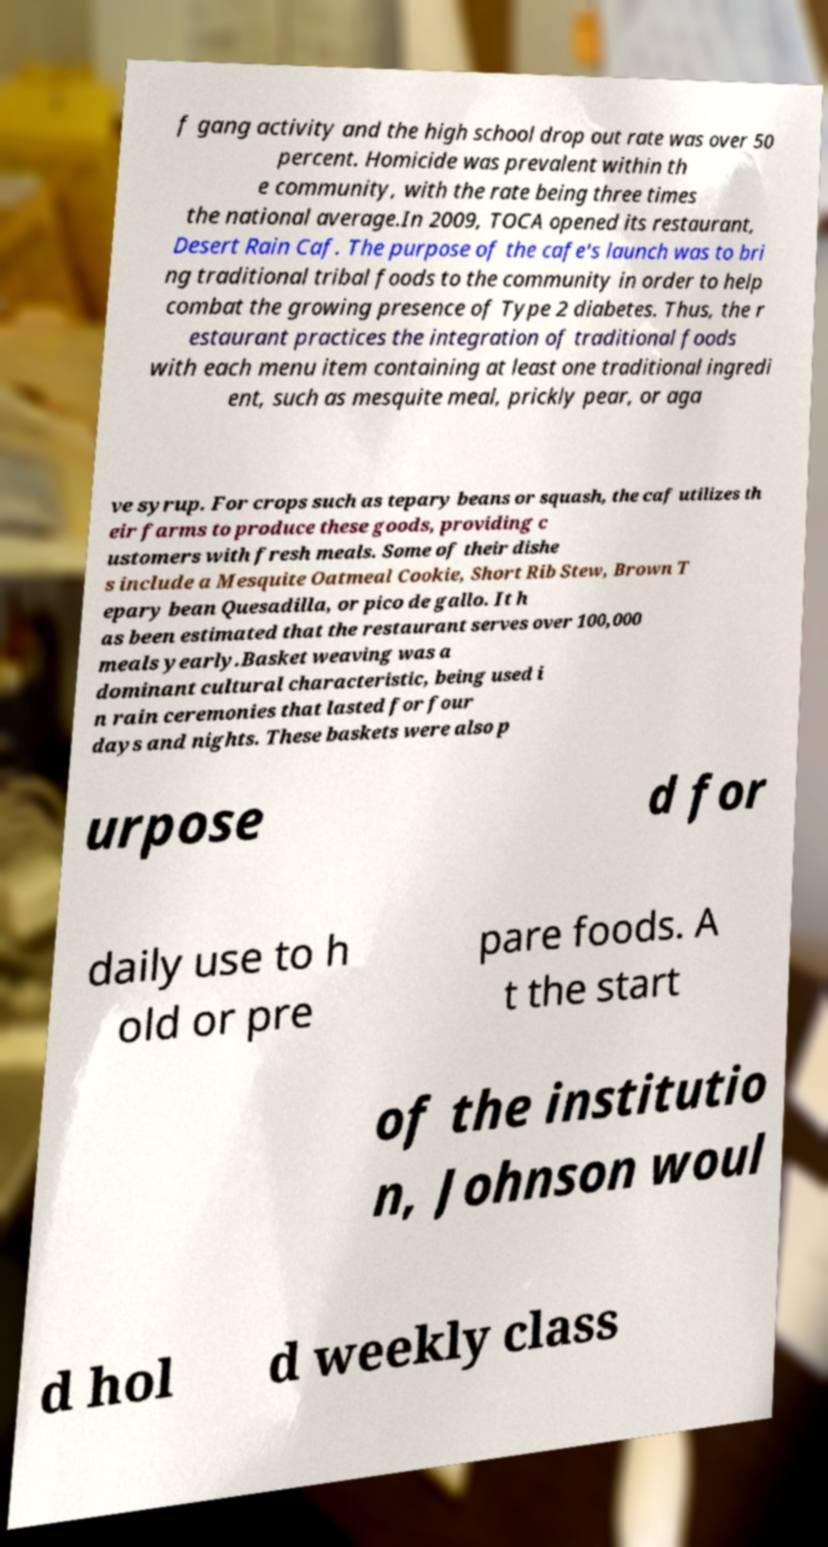Please read and relay the text visible in this image. What does it say? f gang activity and the high school drop out rate was over 50 percent. Homicide was prevalent within th e community, with the rate being three times the national average.In 2009, TOCA opened its restaurant, Desert Rain Caf. The purpose of the cafe's launch was to bri ng traditional tribal foods to the community in order to help combat the growing presence of Type 2 diabetes. Thus, the r estaurant practices the integration of traditional foods with each menu item containing at least one traditional ingredi ent, such as mesquite meal, prickly pear, or aga ve syrup. For crops such as tepary beans or squash, the caf utilizes th eir farms to produce these goods, providing c ustomers with fresh meals. Some of their dishe s include a Mesquite Oatmeal Cookie, Short Rib Stew, Brown T epary bean Quesadilla, or pico de gallo. It h as been estimated that the restaurant serves over 100,000 meals yearly.Basket weaving was a dominant cultural characteristic, being used i n rain ceremonies that lasted for four days and nights. These baskets were also p urpose d for daily use to h old or pre pare foods. A t the start of the institutio n, Johnson woul d hol d weekly class 